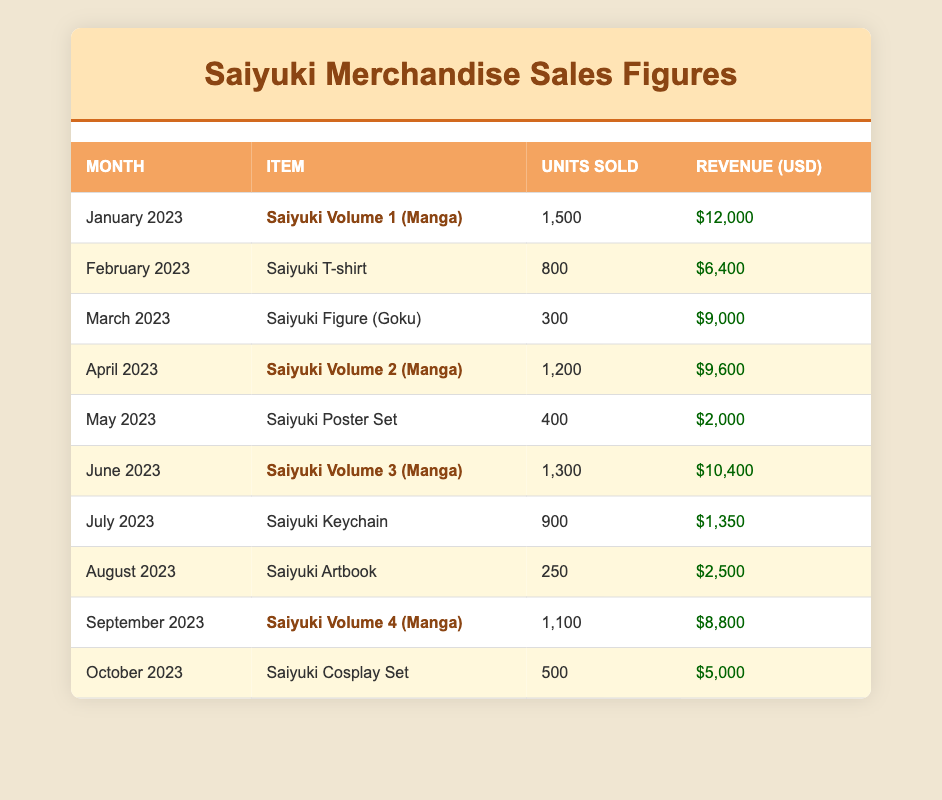What was the revenue for Saiyuki Volume 1 in January 2023? Looking at the table, January 2023 shows that Saiyuki Volume 1 had a revenue of $12,000.
Answer: $12,000 Which item had the highest units sold in June 2023? In June 2023, Saiyuki Volume 3 had the highest units sold at 1,300.
Answer: Saiyuki Volume 3 (Manga) How many units of Saiyuki T-shirts were sold compared to Saiyuki Keychains? Saiyuki T-shirts sold 800 units while Saiyuki Keychains sold 900 units. The difference is 900 - 800 = 100 units sold more for Keychains.
Answer: 100 units What was the total revenue generated from Saiyuki merchandise in April, May, and June 2023? In April 2023, revenue was $9,600; in May 2023, it was $2,000; in June 2023, it was $10,400. Adding these gives 9,600 + 2,000 + 10,400 = 22,000.
Answer: $22,000 Did Saiyuki posters generate more revenue than Saiyuki keychains? The revenue from Saiyuki Posters in May was $2,000, while Saiyuki Keychains earned $1,350 in July, meaning Posters generated more revenue.
Answer: Yes What is the average number of units sold for all Saiyuki items in 2023? To find the average, sum all units sold: 1500 + 800 + 300 + 1200 + 400 + 1300 + 900 + 250 + 1100 + 500 = 6550. There are 10 items, so the average is 6550 / 10 = 655.
Answer: 655 Which month had the least revenue generated from Saiyuki merchandise? By examining the revenue figures, May 2023 had the least at $2,000, which is less than any other month's revenue.
Answer: May 2023 How much revenue was generated from all the Saiyuki manga volumes combined? The manga volumes are: Volume 1 ($12,000), Volume 2 ($9,600), Volume 3 ($10,400), and Volume 4 ($8,800). Adding these gives 12,000 + 9,600 + 10,400 + 8,800 = 40,800 in total revenue.
Answer: $40,800 Was the revenue for Saiyuki Volume 2 higher than that for the Saiyuki Artbook? Saiyuki Volume 2 generated $9,600, and the Artbook generated $2,500. Since 9,600 > 2,500, Volume 2's revenue was higher.
Answer: Yes 